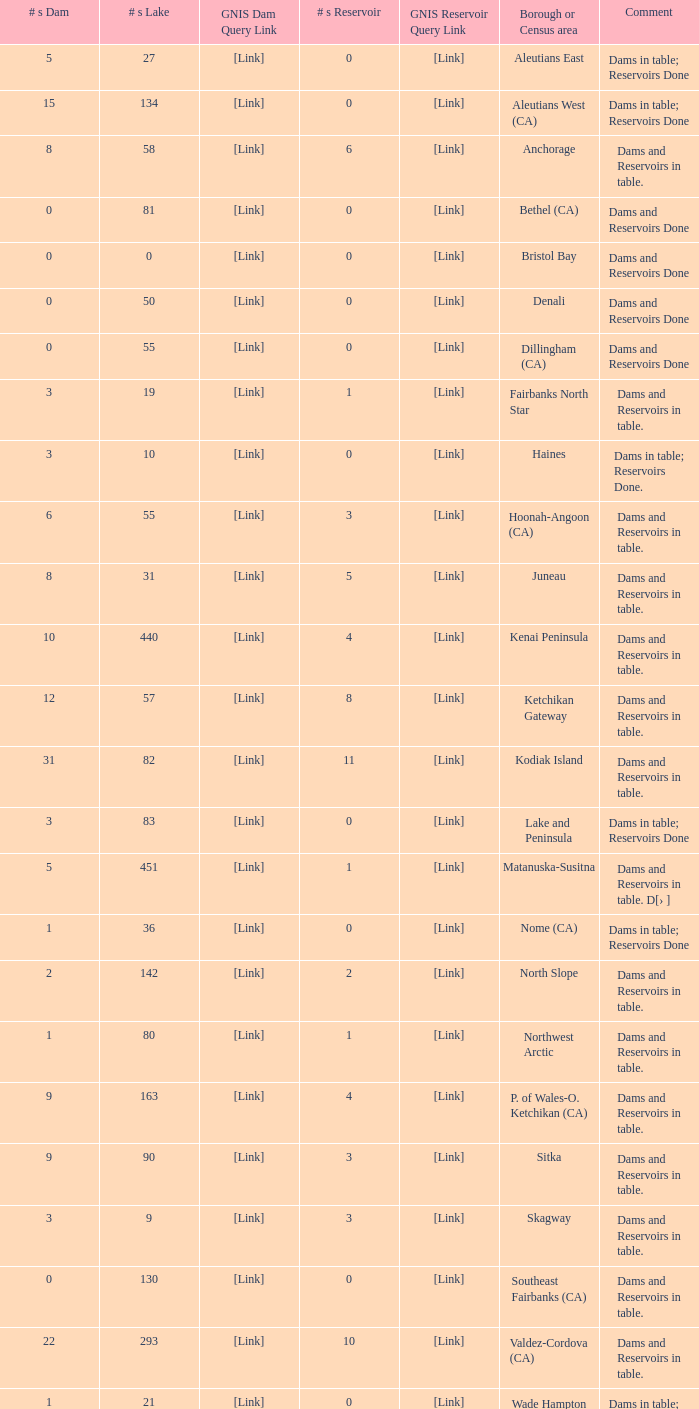Name the most numbers dam and gnis query link for borough or census area for fairbanks north star 3.0. 